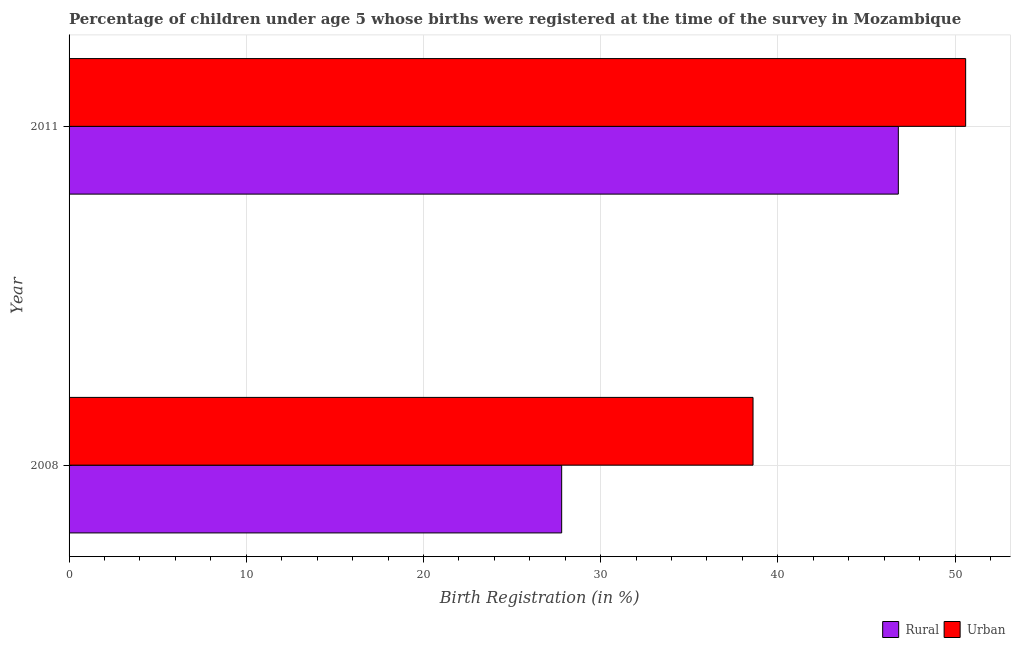How many different coloured bars are there?
Give a very brief answer. 2. Are the number of bars on each tick of the Y-axis equal?
Offer a terse response. Yes. How many bars are there on the 1st tick from the top?
Offer a very short reply. 2. How many bars are there on the 1st tick from the bottom?
Your answer should be compact. 2. What is the label of the 2nd group of bars from the top?
Ensure brevity in your answer.  2008. What is the rural birth registration in 2008?
Make the answer very short. 27.8. Across all years, what is the maximum urban birth registration?
Ensure brevity in your answer.  50.6. Across all years, what is the minimum urban birth registration?
Keep it short and to the point. 38.6. In which year was the rural birth registration minimum?
Your response must be concise. 2008. What is the total urban birth registration in the graph?
Provide a short and direct response. 89.2. What is the difference between the rural birth registration in 2008 and the urban birth registration in 2011?
Offer a terse response. -22.8. What is the average urban birth registration per year?
Keep it short and to the point. 44.6. In the year 2008, what is the difference between the rural birth registration and urban birth registration?
Offer a very short reply. -10.8. What is the ratio of the rural birth registration in 2008 to that in 2011?
Provide a short and direct response. 0.59. In how many years, is the urban birth registration greater than the average urban birth registration taken over all years?
Provide a short and direct response. 1. What does the 1st bar from the top in 2008 represents?
Your response must be concise. Urban. What does the 1st bar from the bottom in 2011 represents?
Your answer should be very brief. Rural. How many bars are there?
Ensure brevity in your answer.  4. Are all the bars in the graph horizontal?
Provide a short and direct response. Yes. How many years are there in the graph?
Provide a short and direct response. 2. Are the values on the major ticks of X-axis written in scientific E-notation?
Ensure brevity in your answer.  No. What is the title of the graph?
Your answer should be compact. Percentage of children under age 5 whose births were registered at the time of the survey in Mozambique. Does "IMF concessional" appear as one of the legend labels in the graph?
Provide a short and direct response. No. What is the label or title of the X-axis?
Your answer should be very brief. Birth Registration (in %). What is the Birth Registration (in %) of Rural in 2008?
Provide a short and direct response. 27.8. What is the Birth Registration (in %) in Urban in 2008?
Your answer should be compact. 38.6. What is the Birth Registration (in %) in Rural in 2011?
Your answer should be very brief. 46.8. What is the Birth Registration (in %) in Urban in 2011?
Provide a succinct answer. 50.6. Across all years, what is the maximum Birth Registration (in %) of Rural?
Your response must be concise. 46.8. Across all years, what is the maximum Birth Registration (in %) in Urban?
Ensure brevity in your answer.  50.6. Across all years, what is the minimum Birth Registration (in %) in Rural?
Your response must be concise. 27.8. Across all years, what is the minimum Birth Registration (in %) in Urban?
Keep it short and to the point. 38.6. What is the total Birth Registration (in %) in Rural in the graph?
Your answer should be compact. 74.6. What is the total Birth Registration (in %) of Urban in the graph?
Make the answer very short. 89.2. What is the difference between the Birth Registration (in %) in Rural in 2008 and that in 2011?
Provide a short and direct response. -19. What is the difference between the Birth Registration (in %) of Urban in 2008 and that in 2011?
Your answer should be very brief. -12. What is the difference between the Birth Registration (in %) of Rural in 2008 and the Birth Registration (in %) of Urban in 2011?
Your response must be concise. -22.8. What is the average Birth Registration (in %) in Rural per year?
Your answer should be very brief. 37.3. What is the average Birth Registration (in %) of Urban per year?
Your answer should be compact. 44.6. What is the ratio of the Birth Registration (in %) of Rural in 2008 to that in 2011?
Offer a very short reply. 0.59. What is the ratio of the Birth Registration (in %) in Urban in 2008 to that in 2011?
Provide a short and direct response. 0.76. What is the difference between the highest and the second highest Birth Registration (in %) in Urban?
Provide a succinct answer. 12. 